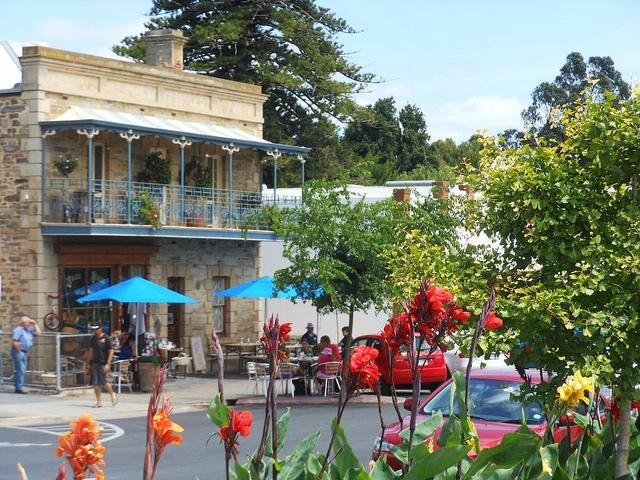Where does this scene take place? restaurant 